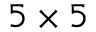Convert formula to latex. <formula><loc_0><loc_0><loc_500><loc_500>5 \times 5</formula> 